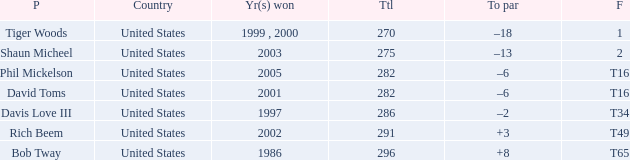What is the to par number of the person who won in 2003? –13. 